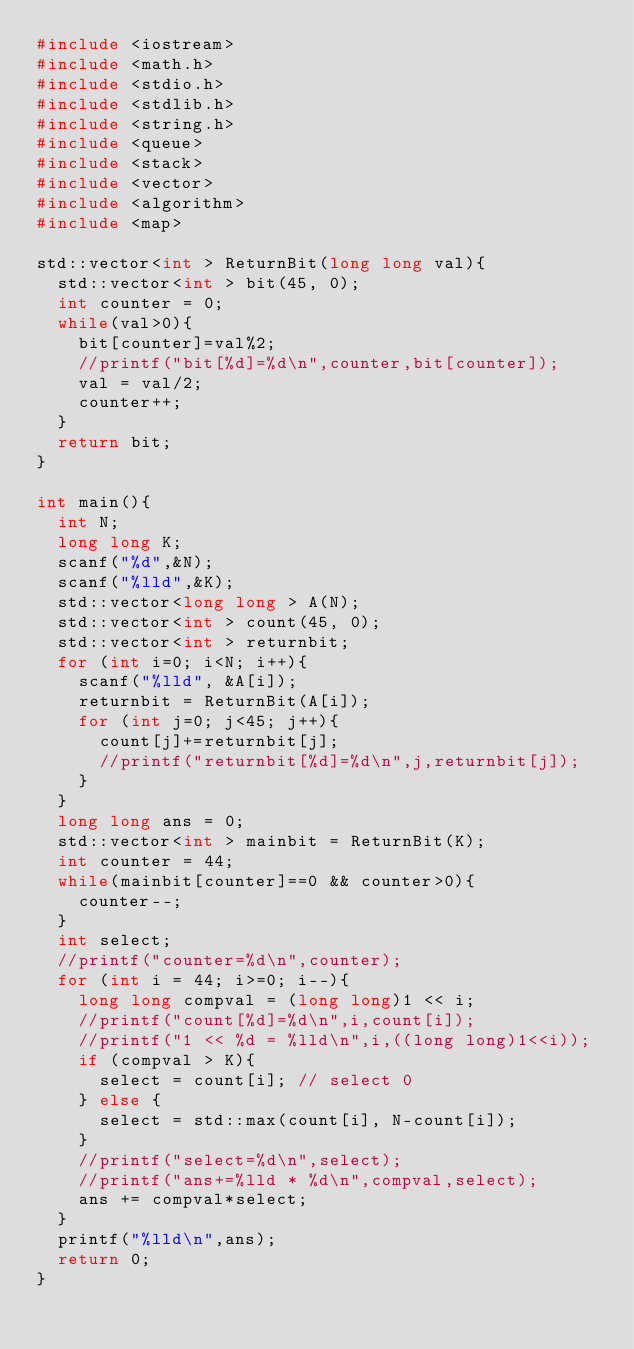Convert code to text. <code><loc_0><loc_0><loc_500><loc_500><_C++_>#include <iostream>
#include <math.h>
#include <stdio.h>
#include <stdlib.h>
#include <string.h>
#include <queue>
#include <stack>
#include <vector>
#include <algorithm>
#include <map>

std::vector<int > ReturnBit(long long val){
  std::vector<int > bit(45, 0);
  int counter = 0;
  while(val>0){
    bit[counter]=val%2;
    //printf("bit[%d]=%d\n",counter,bit[counter]);
    val = val/2;
    counter++;
  }
  return bit;
}

int main(){
  int N;
  long long K;
  scanf("%d",&N);
  scanf("%lld",&K);
  std::vector<long long > A(N);
  std::vector<int > count(45, 0);
  std::vector<int > returnbit;
  for (int i=0; i<N; i++){
    scanf("%lld", &A[i]);
    returnbit = ReturnBit(A[i]);
    for (int j=0; j<45; j++){
      count[j]+=returnbit[j];
      //printf("returnbit[%d]=%d\n",j,returnbit[j]);
    }
  }
  long long ans = 0;
  std::vector<int > mainbit = ReturnBit(K);
  int counter = 44;
  while(mainbit[counter]==0 && counter>0){
    counter--;
  }
  int select;
  //printf("counter=%d\n",counter);
  for (int i = 44; i>=0; i--){
    long long compval = (long long)1 << i;
    //printf("count[%d]=%d\n",i,count[i]);
    //printf("1 << %d = %lld\n",i,((long long)1<<i));
    if (compval > K){
      select = count[i]; // select 0
    } else {
      select = std::max(count[i], N-count[i]);
    }
    //printf("select=%d\n",select);
    //printf("ans+=%lld * %d\n",compval,select);
    ans += compval*select;
  }
  printf("%lld\n",ans);
  return 0;
}
</code> 